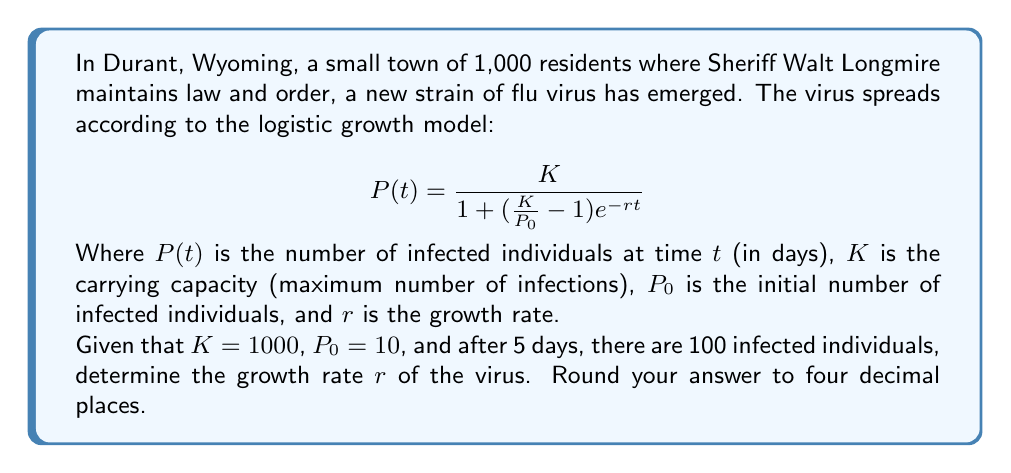Provide a solution to this math problem. To solve this problem, we need to use the logistic growth model equation and the given information to find the value of $r$. Let's approach this step-by-step:

1) We know that after 5 days, there are 100 infected individuals. So we can set up the equation:

   $$100 = \frac{1000}{1 + (\frac{1000}{10} - 1)e^{-5r}}$$

2) Let's simplify the right side of the equation:

   $$100 = \frac{1000}{1 + 99e^{-5r}}$$

3) Now, let's solve for $e^{-5r}$:

   $$100(1 + 99e^{-5r}) = 1000$$
   $$100 + 9900e^{-5r} = 1000$$
   $$9900e^{-5r} = 900$$
   $$e^{-5r} = \frac{900}{9900} = \frac{10}{110} = \frac{1}{11}$$

4) Now we can solve for $r$:

   $$-5r = \ln(\frac{1}{11})$$
   $$r = -\frac{1}{5}\ln(\frac{1}{11})$$
   $$r = \frac{1}{5}\ln(11)$$

5) Using a calculator and rounding to four decimal places:

   $$r \approx 0.4796$$

This growth rate represents the speed at which the virus is spreading through the community of Durant.
Answer: $r \approx 0.4796$ 